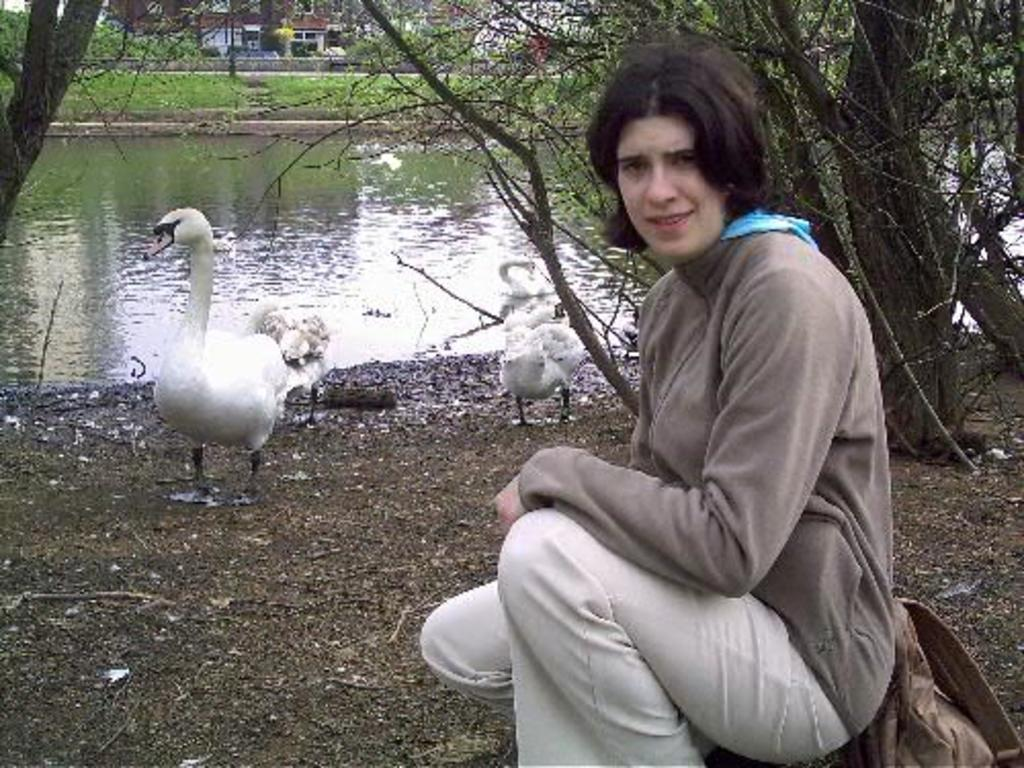What type of living being is present in the image? There is a human in the image. What structures can be seen in the background? There are buildings in the image. What type of vegetation is present in the image? There are trees in the image. What animals are visible in the image? There are swans in the water, and some swans are on the ground. What object is on the ground? There is a bag on the ground. What type of history can be seen in the image? There is no specific historical event or reference in the image; it features a human, buildings, trees, swans, and a bag on the ground. What tool is being used by the swans in the image? Swans do not use tools, and there is no wrench or any other tool present in the image. 